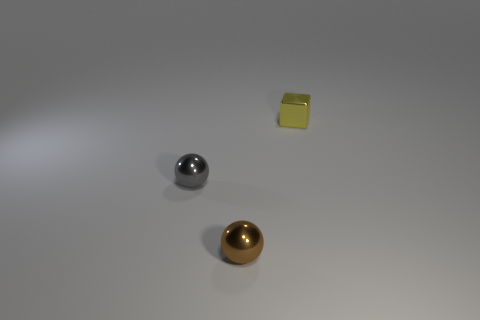Do the brown sphere that is in front of the small gray metal ball and the cube have the same material?
Make the answer very short. Yes. What number of small gray things are the same shape as the yellow thing?
Make the answer very short. 0. What number of big objects are either red shiny blocks or yellow shiny objects?
Provide a short and direct response. 0. Is the color of the object that is left of the tiny brown shiny ball the same as the tiny cube?
Your answer should be very brief. No. Does the tiny ball that is in front of the small gray metal thing have the same color as the tiny shiny thing that is behind the gray metallic object?
Give a very brief answer. No. Is there a yellow thing made of the same material as the brown object?
Give a very brief answer. Yes. How many yellow things are either metallic objects or large matte cylinders?
Provide a short and direct response. 1. Are there more tiny yellow metal objects behind the small yellow thing than gray shiny objects?
Keep it short and to the point. No. Do the shiny cube and the brown metal ball have the same size?
Provide a succinct answer. Yes. What color is the block that is made of the same material as the brown ball?
Provide a succinct answer. Yellow. 